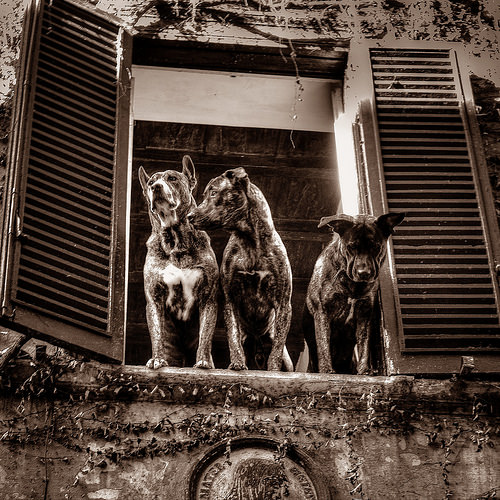<image>
Is the dog to the left of the dog? Yes. From this viewpoint, the dog is positioned to the left side relative to the dog. 